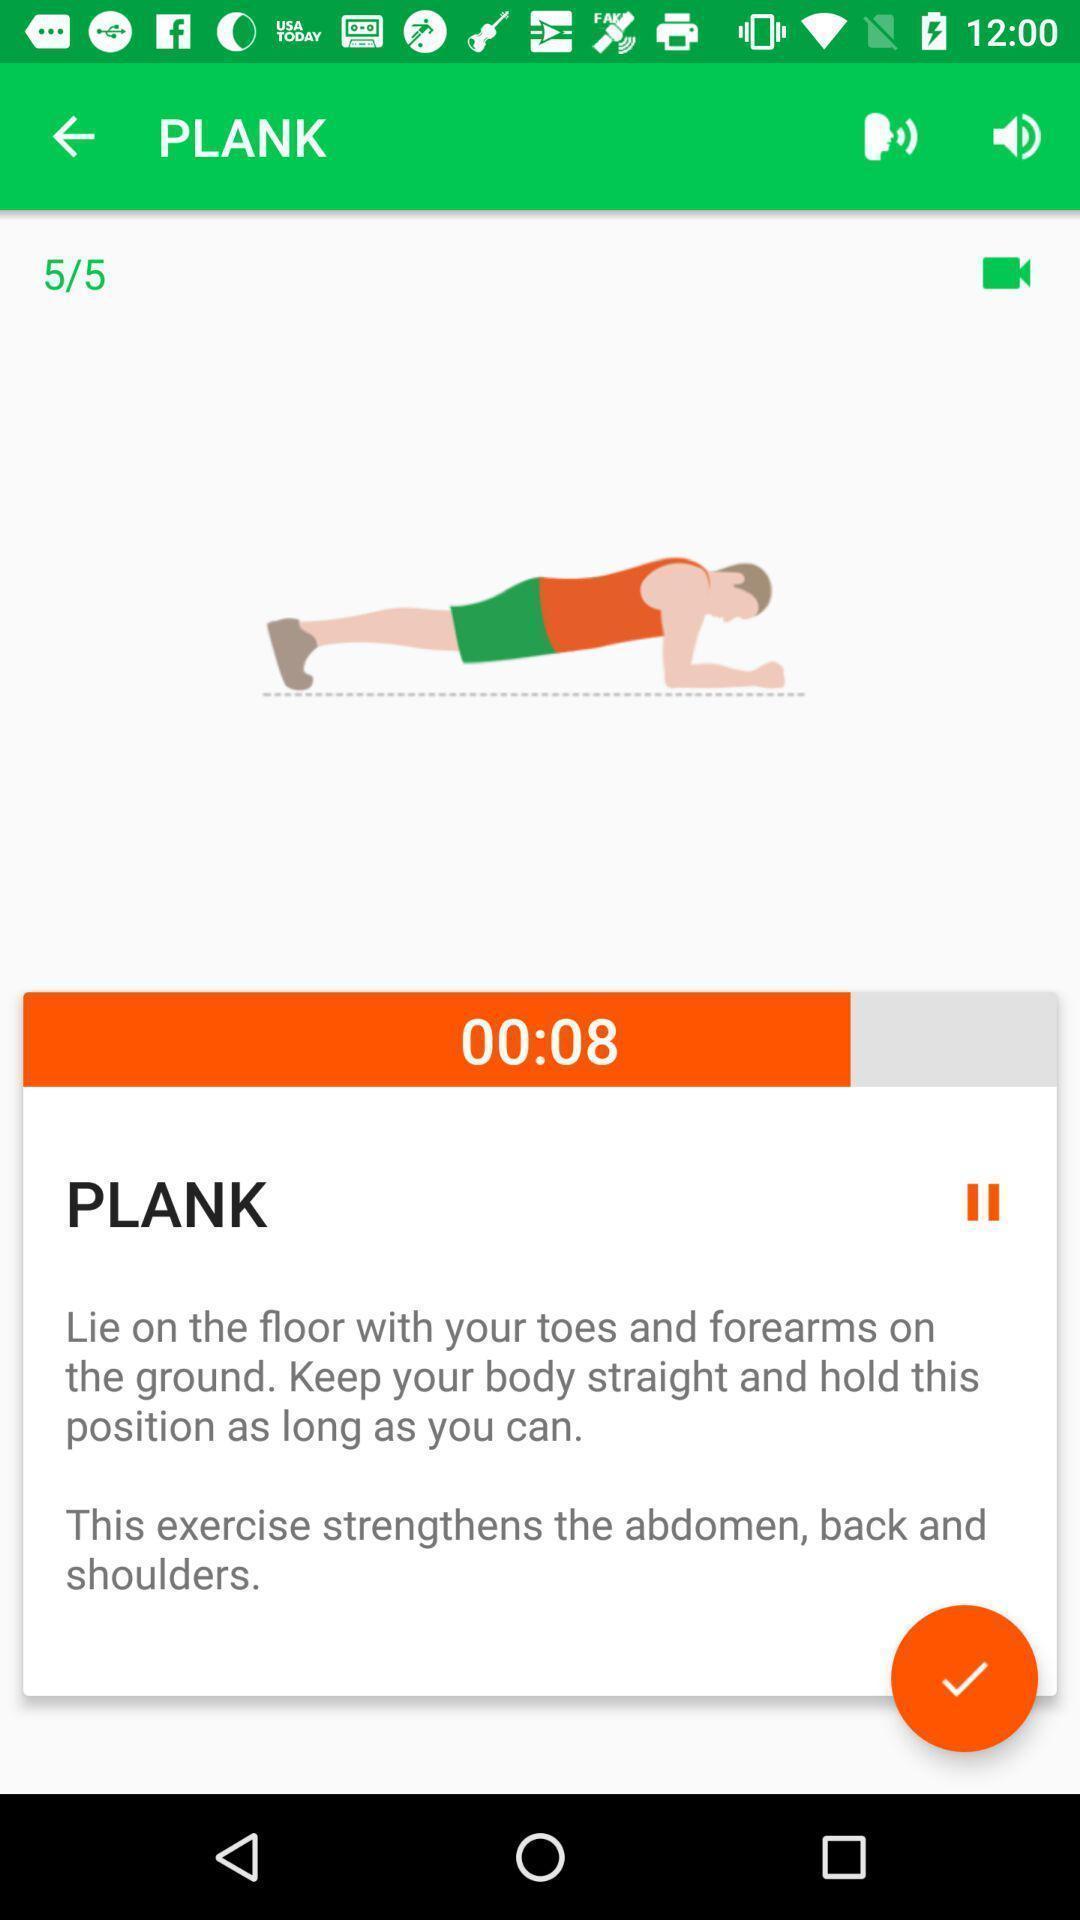Tell me about the visual elements in this screen capture. Screen displaying the image of plank. 